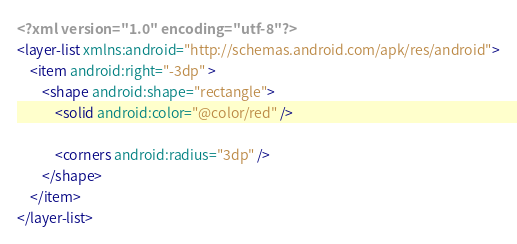Convert code to text. <code><loc_0><loc_0><loc_500><loc_500><_XML_><?xml version="1.0" encoding="utf-8"?>
<layer-list xmlns:android="http://schemas.android.com/apk/res/android">
    <item android:right="-3dp" >
        <shape android:shape="rectangle">
            <solid android:color="@color/red" />

            <corners android:radius="3dp" />
        </shape>
    </item>
</layer-list></code> 